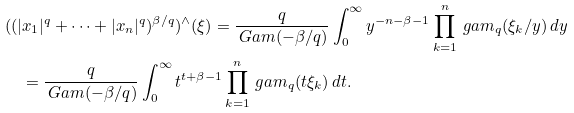Convert formula to latex. <formula><loc_0><loc_0><loc_500><loc_500>& ( ( | x _ { 1 } | ^ { q } + \cdots + | x _ { n } | ^ { q } ) ^ { \beta / q } ) ^ { \wedge } ( \xi ) = \frac { q } { \ G a m ( - \beta / q ) } \int _ { 0 } ^ { \infty } y ^ { - n - \beta - 1 } \prod _ { k = 1 } ^ { n } \ g a m _ { q } ( \xi _ { k } / y ) \, d y \\ & \quad = \frac { q } { \ G a m ( - \beta / q ) } \int _ { 0 } ^ { \infty } t ^ { t + \beta - 1 } \prod _ { k = 1 } ^ { n } \ g a m _ { q } ( t \xi _ { k } ) \, d t .</formula> 